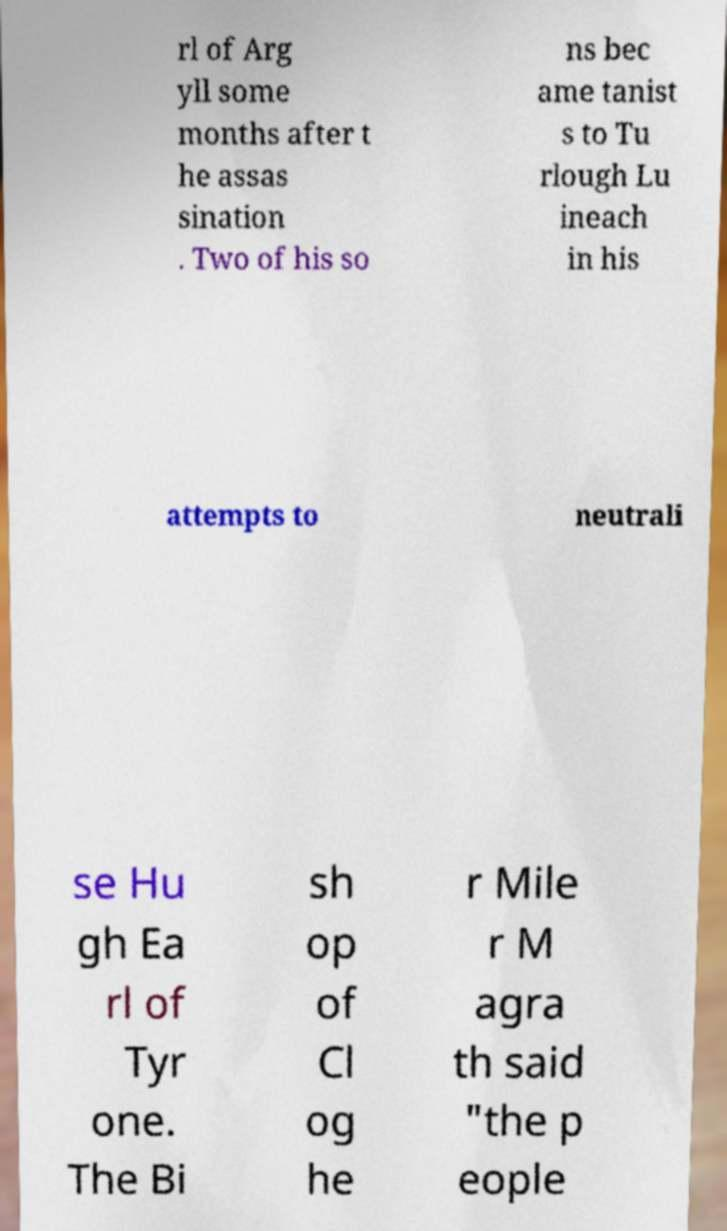There's text embedded in this image that I need extracted. Can you transcribe it verbatim? rl of Arg yll some months after t he assas sination . Two of his so ns bec ame tanist s to Tu rlough Lu ineach in his attempts to neutrali se Hu gh Ea rl of Tyr one. The Bi sh op of Cl og he r Mile r M agra th said "the p eople 